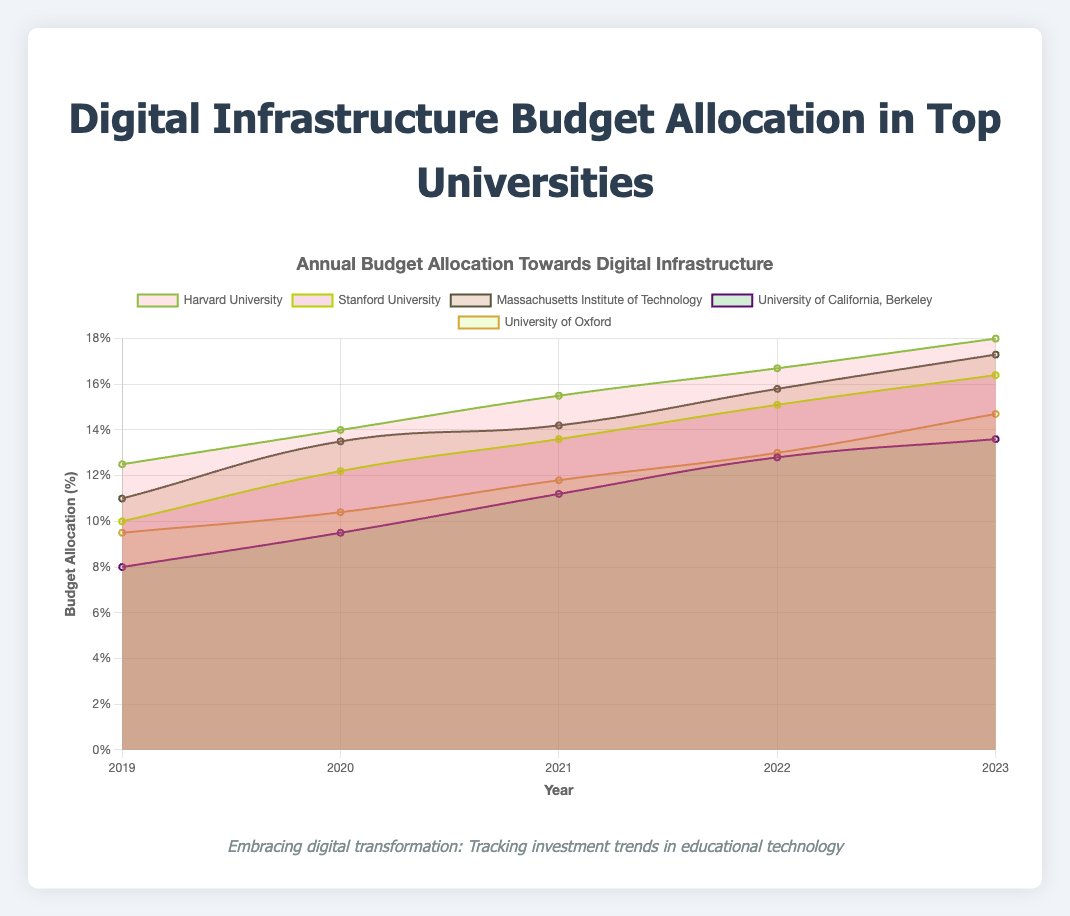What is the title of the figure? The title is displayed at the top of the figure. It reads "Annual Budget Allocation Towards Digital Infrastructure."
Answer: Annual Budget Allocation Towards Digital Infrastructure What is displayed on the x-axis? The x-axis shows the years for which the budget allocation data is provided. These are "2019", "2020", "2021", "2022", and "2023".
Answer: Years: 2019, 2020, 2021, 2022, 2023 Which institution had the highest budget allocation in 2023? To find this, look at the point corresponding to 2023 for each institution and compare the values. Harvard University has the highest value at 18.0%.
Answer: Harvard University In which year did the budget allocation for Stanford University first exceed 10%? Locate the Stanford University data series and identify the first year where the allocation surpasses 10%. This occurs in 2020 when the allocation is 12.2%.
Answer: 2020 What is the trend of budget allocation for the Massachusetts Institute of Technology from 2019 to 2023? For the Massachusetts Institute of Technology, observe the values from 2019 (11.0%) to 2023 (17.3%). The trend shows a consistent increase each year.
Answer: Increasing How much did the budget allocation for the University of California, Berkeley grow from 2019 to 2023? Subtract the 2019 value (8.0%) from the 2023 value (13.6%) for the University of California, Berkeley. The growth is 5.6%.
Answer: 5.6% Compare the budget allocation between Stanford University and the University of Oxford in 2021. Which institution allocated more? Examine the values for both universities in 2021. Stanford University allocated 13.6%, and the University of Oxford allocated 11.8%. Stanford University allocated more.
Answer: Stanford University What is the average budget allocation of Harvard University from 2019 to 2023? Sum the yearly allocations (12.5 + 14.0 + 15.5 + 16.7 + 18.0) and divide by the number of years (5). The average is (12.5 + 14.0 + 15.5 + 16.7 + 18.0)/5 = 15.34%.
Answer: 15.34% Between 2021 and 2022, which institution saw the largest increase in budget allocation? Calculate the increase for each institution by subtracting the 2021 value from the 2022 value, then identify the largest increase. MIT (1.6%), Stanford (1.5%), Harvard (1.2%), Oxford (1.2%), Berkeley (1.6%). Both MIT and Berkeley saw the largest increase of 1.6%.
Answer: Massachusetts Institute of Technology and University of California, Berkeley Which year did the University of Oxford's budget allocation first reach double digits? Check the budget allocation values for the University of Oxford and find the first year it is 10% or higher. This occurs in 2020 (10.4%).
Answer: 2020 